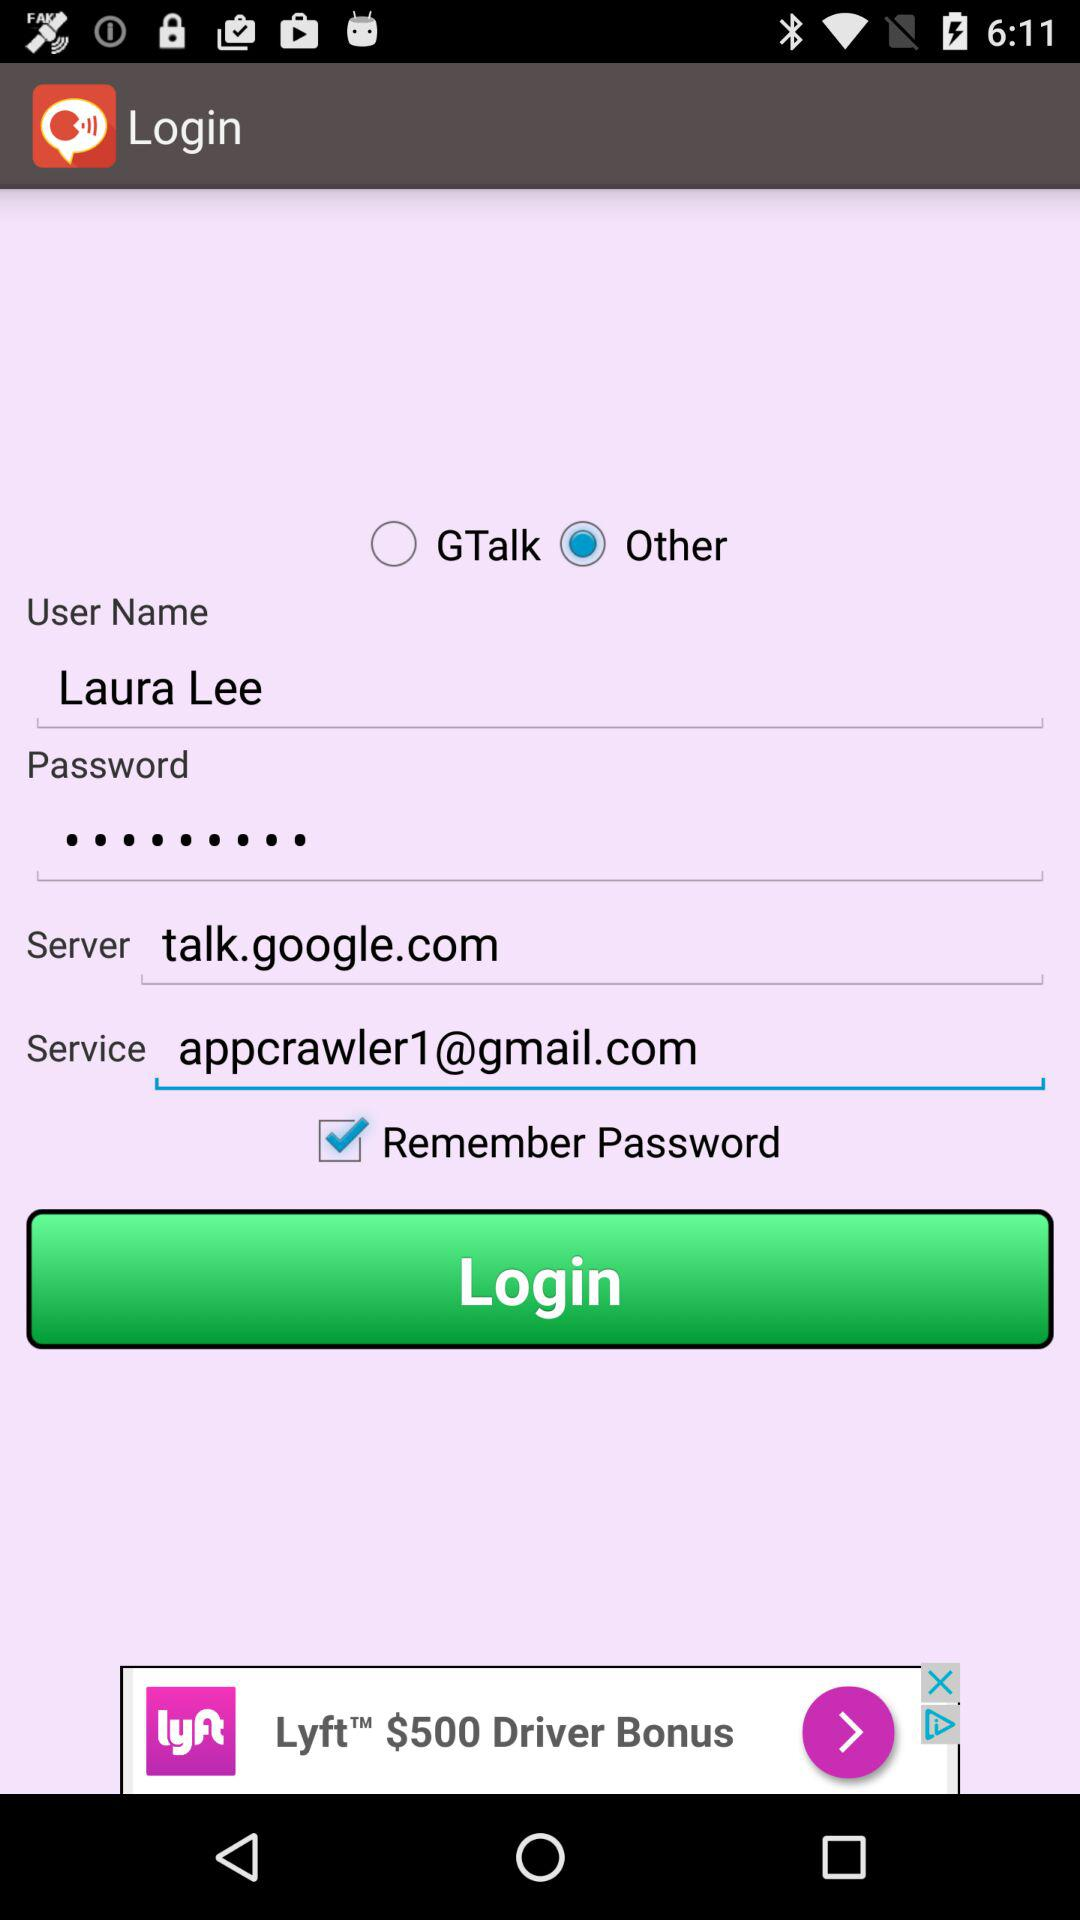Which option is marked as checked? The option that is marked as checked is "Remember Password". 